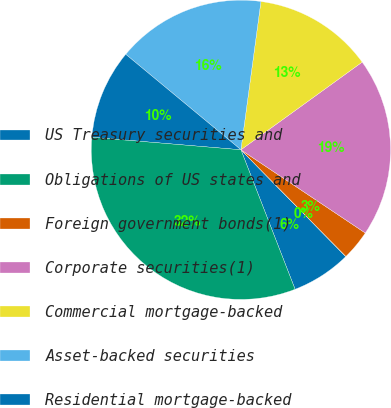<chart> <loc_0><loc_0><loc_500><loc_500><pie_chart><fcel>US Treasury securities and<fcel>Obligations of US states and<fcel>Foreign government bonds(1)<fcel>Corporate securities(1)<fcel>Commercial mortgage-backed<fcel>Asset-backed securities<fcel>Residential mortgage-backed<fcel>Total<nl><fcel>6.46%<fcel>0.02%<fcel>3.24%<fcel>19.35%<fcel>12.9%<fcel>16.12%<fcel>9.68%<fcel>32.23%<nl></chart> 